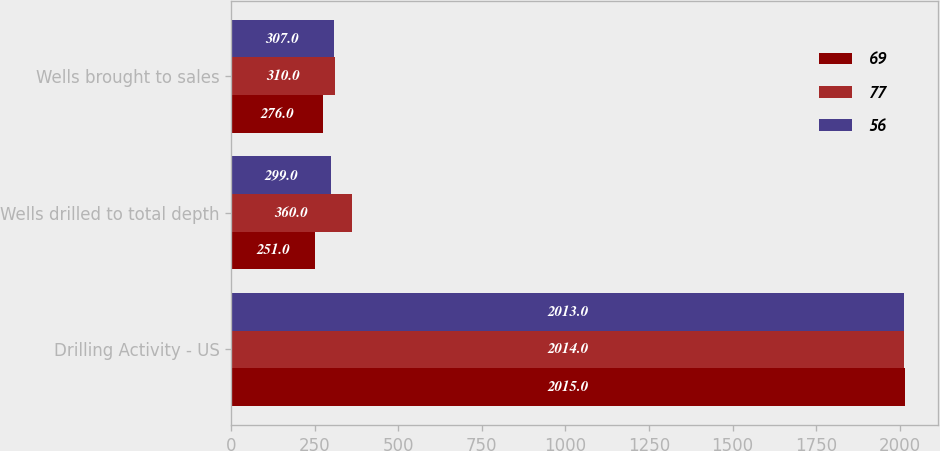Convert chart. <chart><loc_0><loc_0><loc_500><loc_500><stacked_bar_chart><ecel><fcel>Drilling Activity - US<fcel>Wells drilled to total depth<fcel>Wells brought to sales<nl><fcel>69<fcel>2015<fcel>251<fcel>276<nl><fcel>77<fcel>2014<fcel>360<fcel>310<nl><fcel>56<fcel>2013<fcel>299<fcel>307<nl></chart> 